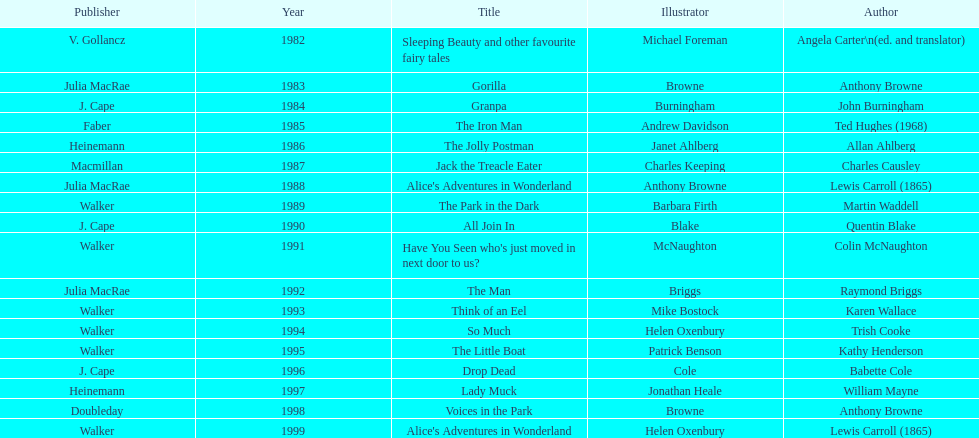What is the only title listed for 1999? Alice's Adventures in Wonderland. 